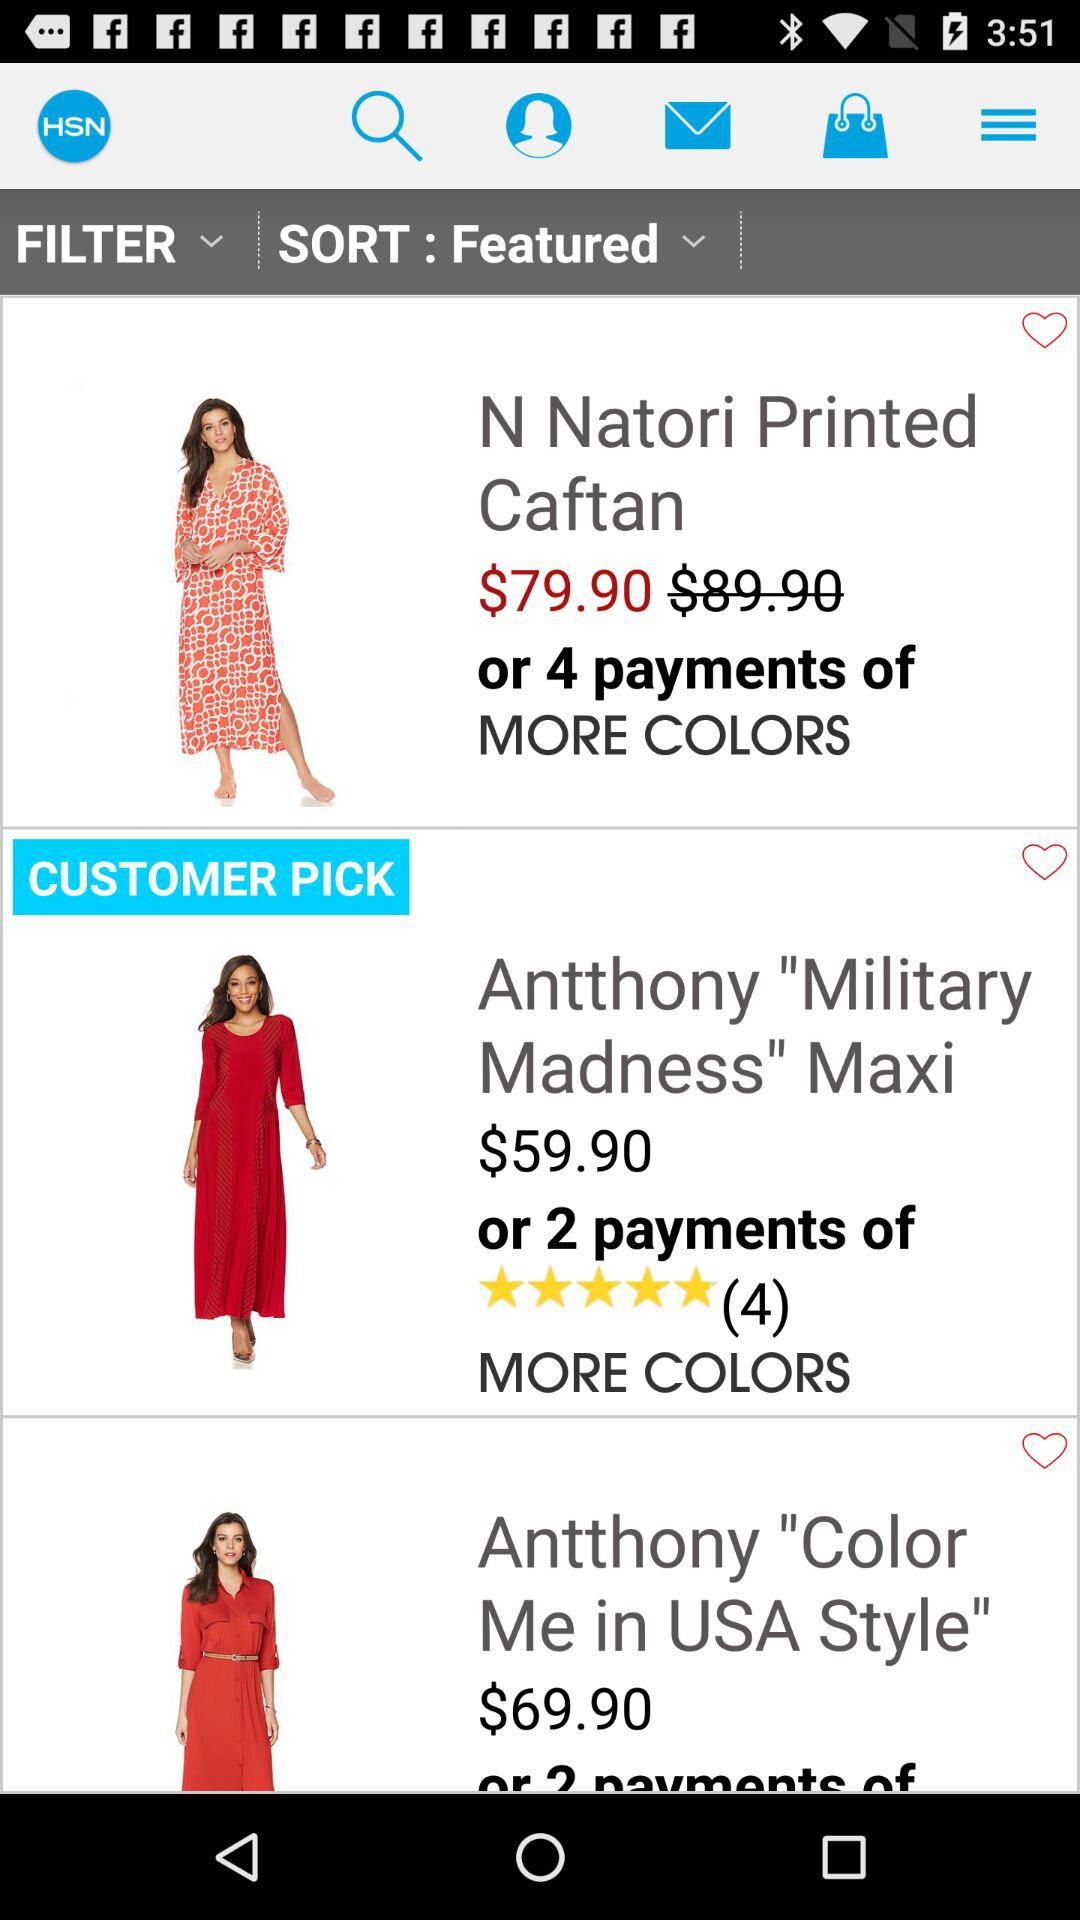How many more colours are there in Antthony military madness maxi?
When the provided information is insufficient, respond with <no answer>. <no answer> 